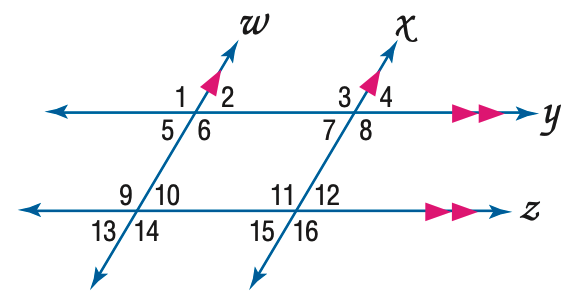Answer the mathemtical geometry problem and directly provide the correct option letter.
Question: In the figure, m \angle 12 = 64. Find the measure of \angle 8.
Choices: A: 86 B: 96 C: 106 D: 116 D 